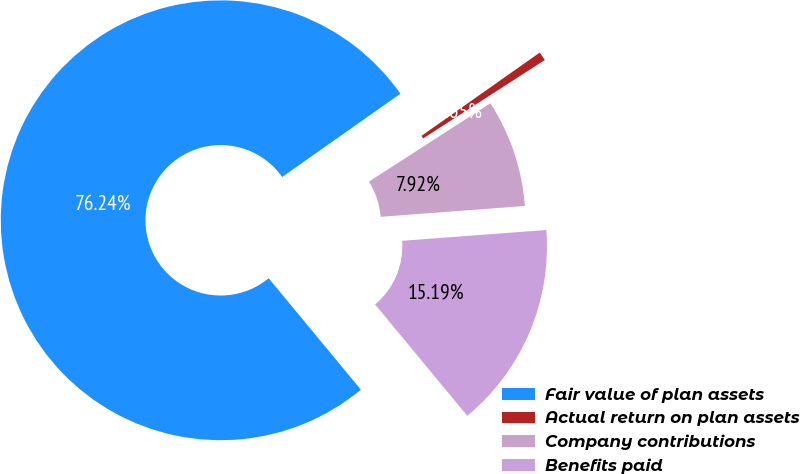<chart> <loc_0><loc_0><loc_500><loc_500><pie_chart><fcel>Fair value of plan assets<fcel>Actual return on plan assets<fcel>Company contributions<fcel>Benefits paid<nl><fcel>76.24%<fcel>0.65%<fcel>7.92%<fcel>15.19%<nl></chart> 